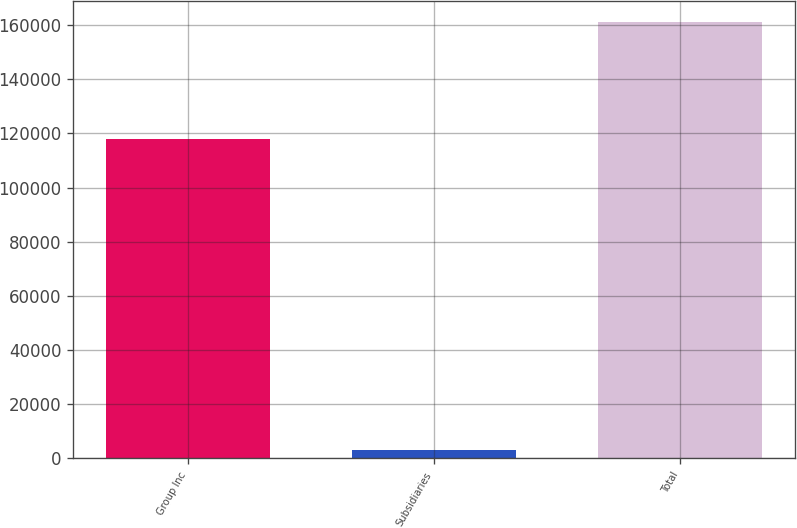Convert chart to OTSL. <chart><loc_0><loc_0><loc_500><loc_500><bar_chart><fcel>Group Inc<fcel>Subsidiaries<fcel>Total<nl><fcel>117899<fcel>2967<fcel>160965<nl></chart> 